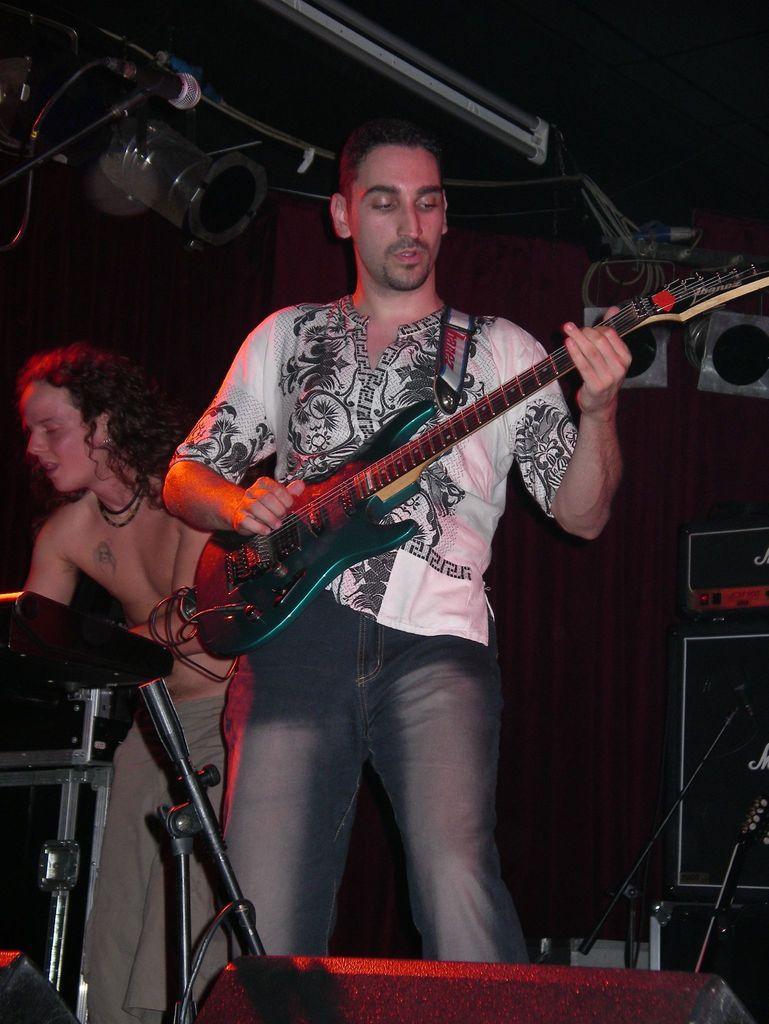Describe this image in one or two sentences. In this picture we can see man holding guitar in his hand and playing it and beside to him other person playing piano and we have mic stands, radio, wall beside to them. 